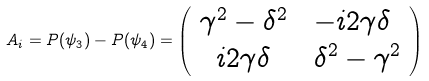Convert formula to latex. <formula><loc_0><loc_0><loc_500><loc_500>A _ { i } = P ( \psi _ { 3 } ) - P ( \psi _ { 4 } ) = \left ( \begin{array} { c l } \gamma ^ { 2 } - \delta ^ { 2 } & \ - i 2 \gamma \delta \\ i 2 \gamma \delta & \ \delta ^ { 2 } - \gamma ^ { 2 } \end{array} \right )</formula> 